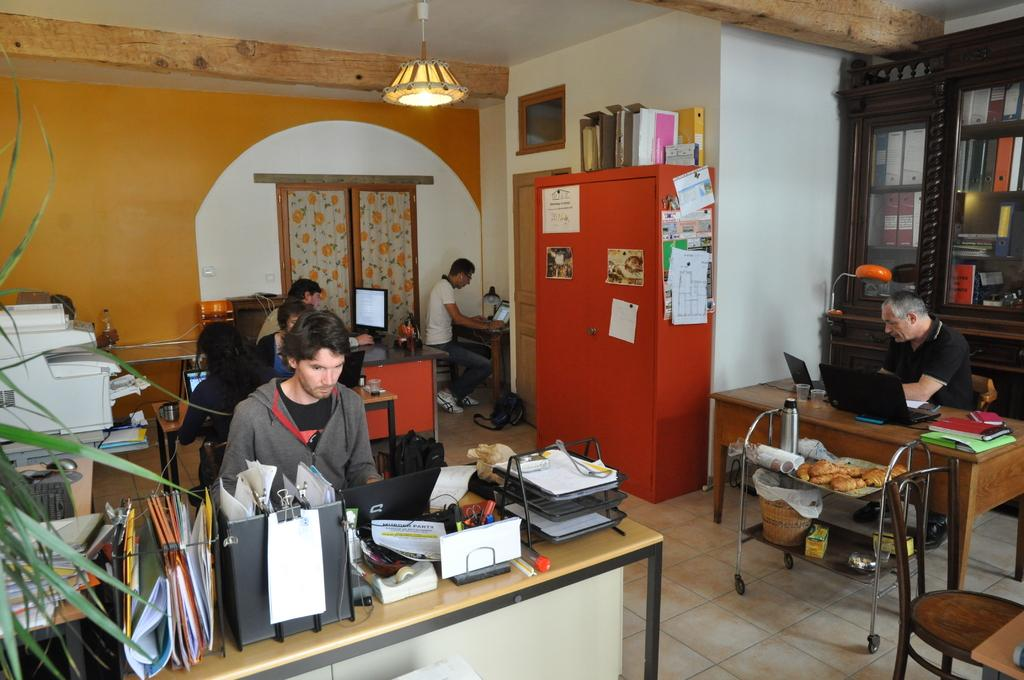What type of lighting is available in the room? The room has a light. What can be found on the shelf in the room? There is a shelf with books in the room. What furniture is present in the room? There are tables and chairs in the room. What are the people in the room doing? People are working in the room. What type of work-related items can be found in the room? There are files, laptops, and printers in the room. Can you see a carriage in the room? There is no carriage present in the room; it is an office setting with work-related items. 